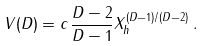Convert formula to latex. <formula><loc_0><loc_0><loc_500><loc_500>V ( D ) = c \, \frac { D - 2 } { D - 1 } X ^ { ( D - 1 ) / ( D - 2 ) } _ { h } \, .</formula> 